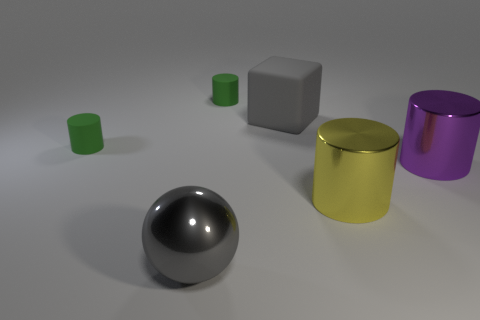Subtract all big purple cylinders. How many cylinders are left? 3 Add 3 tiny cyan metallic spheres. How many objects exist? 9 Subtract all yellow cylinders. How many cylinders are left? 3 Add 4 large red rubber cylinders. How many large red rubber cylinders exist? 4 Subtract 0 red cubes. How many objects are left? 6 Subtract all cylinders. How many objects are left? 2 Subtract 1 cylinders. How many cylinders are left? 3 Subtract all brown blocks. Subtract all purple cylinders. How many blocks are left? 1 Subtract all yellow balls. How many yellow cylinders are left? 1 Subtract all gray objects. Subtract all cylinders. How many objects are left? 0 